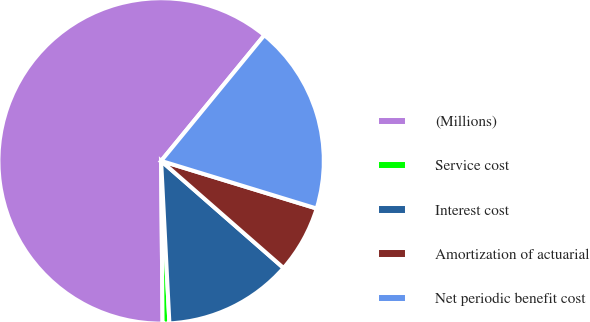Convert chart. <chart><loc_0><loc_0><loc_500><loc_500><pie_chart><fcel>(Millions)<fcel>Service cost<fcel>Interest cost<fcel>Amortization of actuarial<fcel>Net periodic benefit cost<nl><fcel>61.08%<fcel>0.67%<fcel>12.75%<fcel>6.71%<fcel>18.79%<nl></chart> 